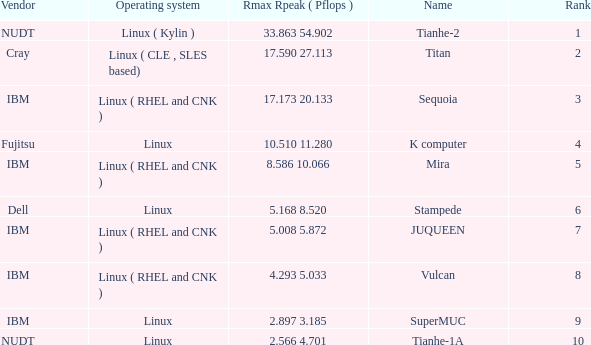What is the name of Rank 5? Mira. 